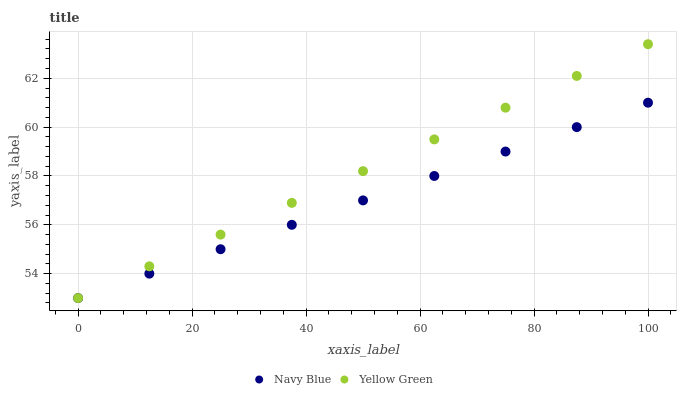Does Navy Blue have the minimum area under the curve?
Answer yes or no. Yes. Does Yellow Green have the maximum area under the curve?
Answer yes or no. Yes. Does Yellow Green have the minimum area under the curve?
Answer yes or no. No. Is Navy Blue the smoothest?
Answer yes or no. Yes. Is Yellow Green the roughest?
Answer yes or no. Yes. Is Yellow Green the smoothest?
Answer yes or no. No. Does Navy Blue have the lowest value?
Answer yes or no. Yes. Does Yellow Green have the highest value?
Answer yes or no. Yes. Does Navy Blue intersect Yellow Green?
Answer yes or no. Yes. Is Navy Blue less than Yellow Green?
Answer yes or no. No. Is Navy Blue greater than Yellow Green?
Answer yes or no. No. 